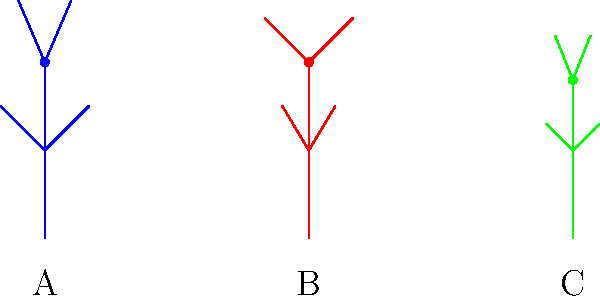In the stick figure diagrams above, which posture (A, B, or C) would be most suitable for an actor portraying a commanding military officer in a war drama? To analyze the body language and posture of the stick figures for a commanding military officer role, we need to consider the following aspects:

1. Figure A (blue):
   - Neutral stance
   - Arms and legs at moderate angles
   - Head in a centered position

2. Figure B (red):
   - Wider stance with feet apart
   - Arms outstretched and raised
   - Head held high

3. Figure C (green):
   - Narrower stance with feet close together
   - Arms close to the body and slightly bent
   - Head slightly lowered

For a commanding military officer in a war drama, we want to convey authority, confidence, and control. The posture that best represents these qualities is Figure B (red) because:

1. The wider stance suggests stability and a strong presence.
2. The outstretched and raised arms indicate openness, assertiveness, and the ability to command attention.
3. The head held high portrays confidence and authority.

In contrast, Figure A appears neutral and lacks the commanding presence required for the role, while Figure C's posture suggests submissiveness or uncertainty, which is unsuitable for a military officer character.
Answer: B 